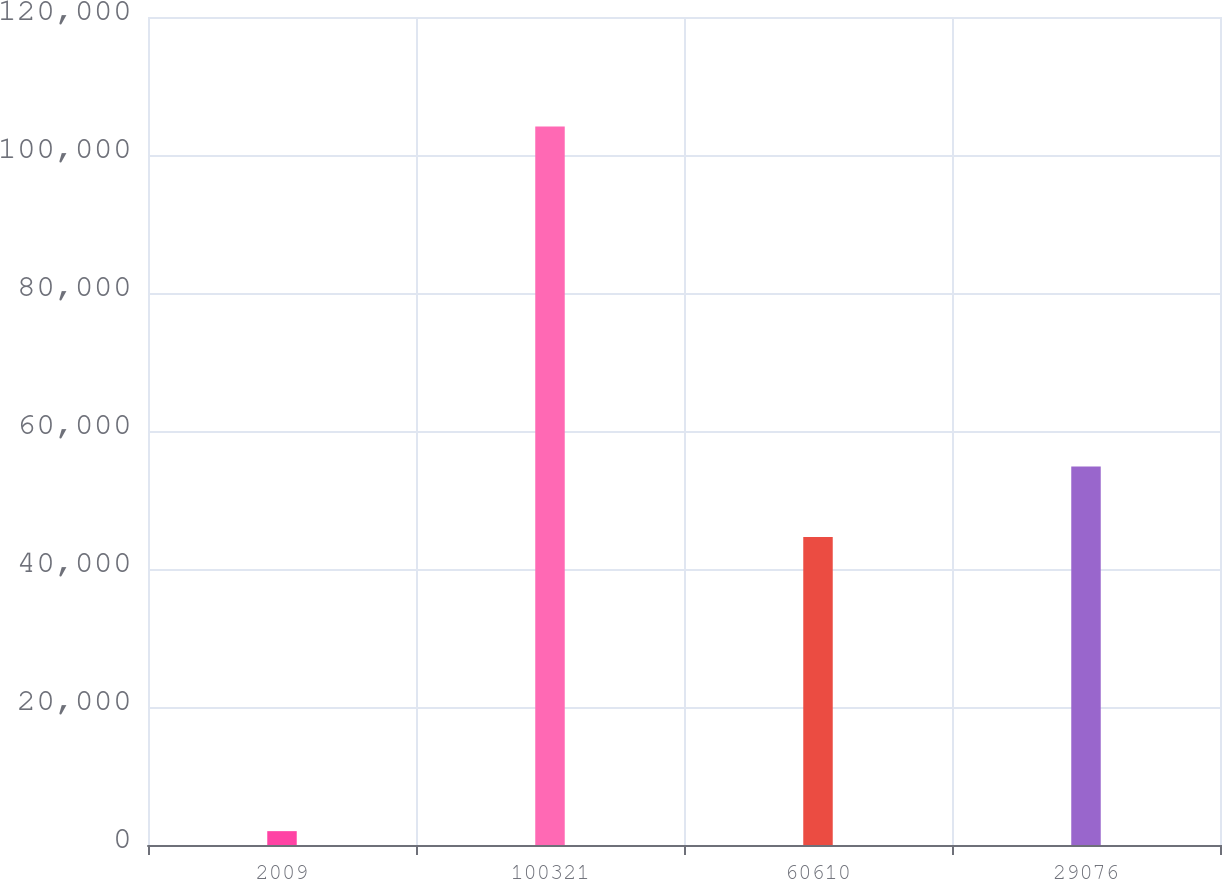Convert chart to OTSL. <chart><loc_0><loc_0><loc_500><loc_500><bar_chart><fcel>2009<fcel>100321<fcel>60610<fcel>29076<nl><fcel>2008<fcel>104126<fcel>44627<fcel>54838.8<nl></chart> 